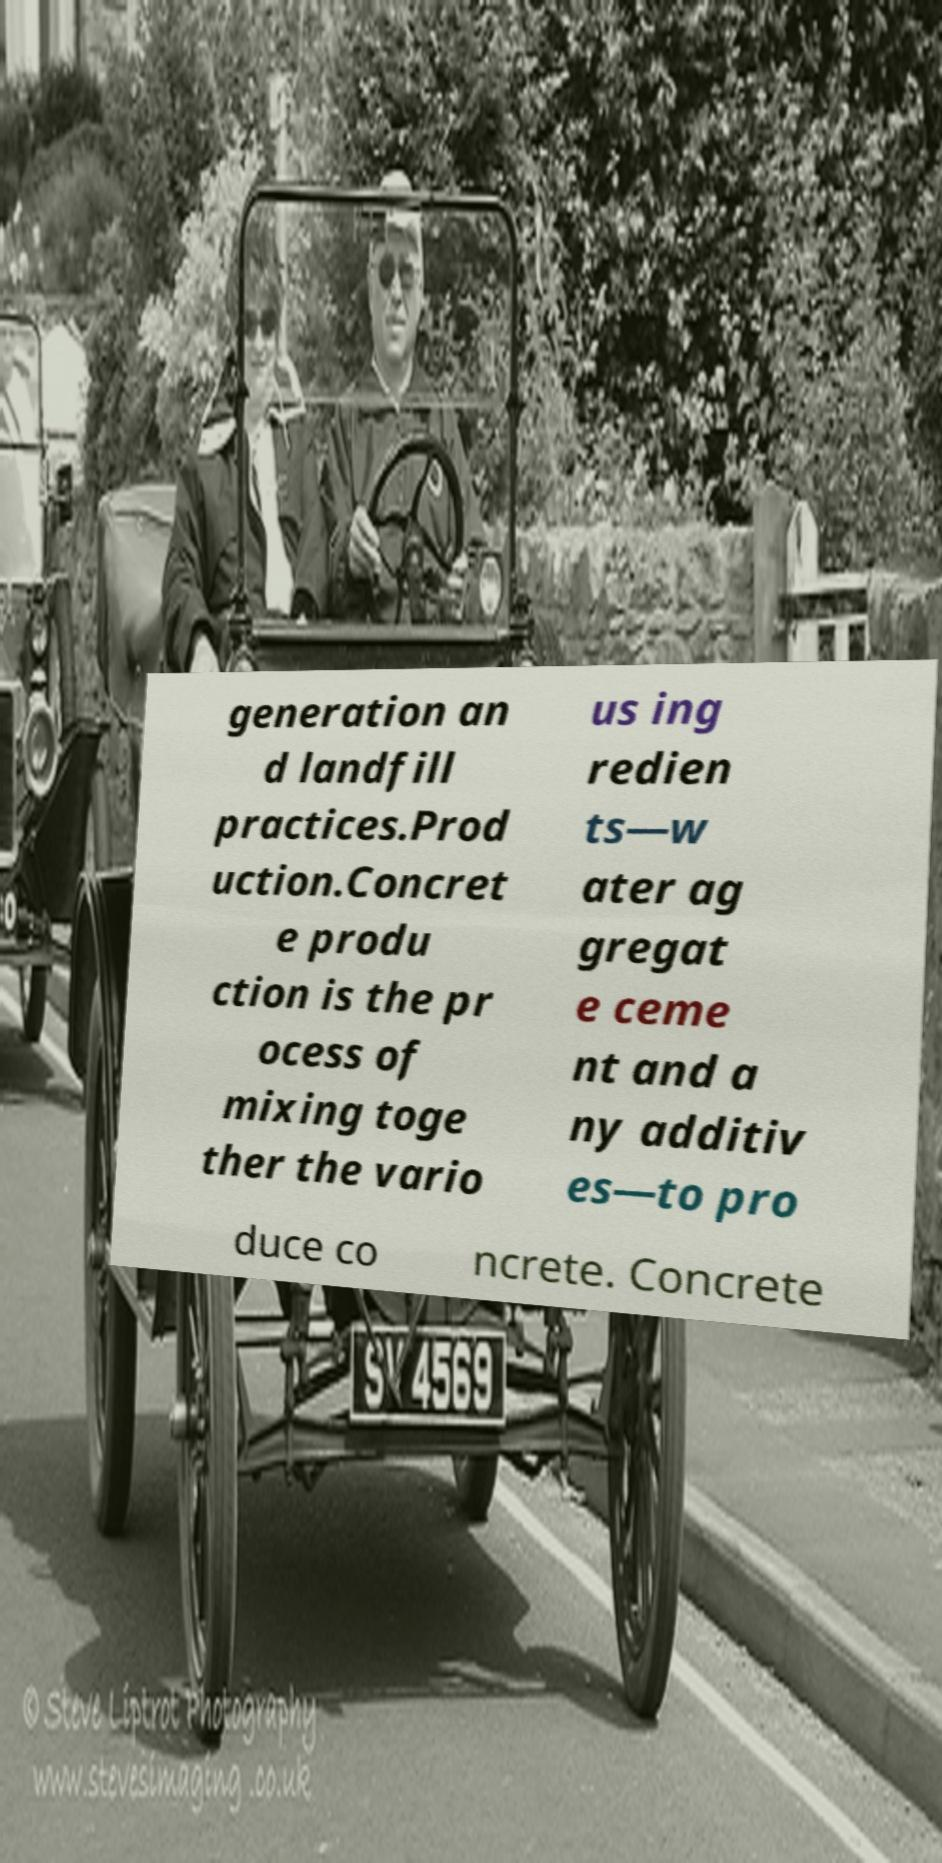For documentation purposes, I need the text within this image transcribed. Could you provide that? generation an d landfill practices.Prod uction.Concret e produ ction is the pr ocess of mixing toge ther the vario us ing redien ts—w ater ag gregat e ceme nt and a ny additiv es—to pro duce co ncrete. Concrete 